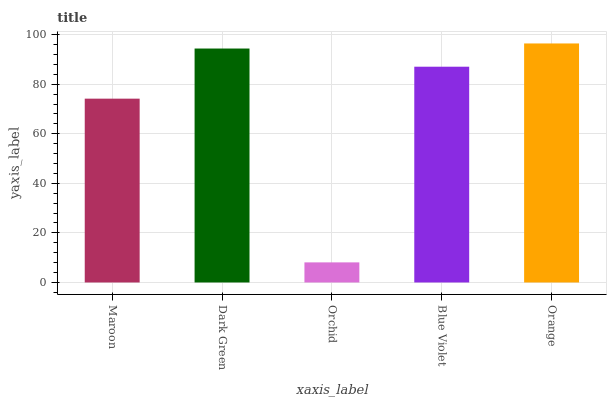Is Orchid the minimum?
Answer yes or no. Yes. Is Orange the maximum?
Answer yes or no. Yes. Is Dark Green the minimum?
Answer yes or no. No. Is Dark Green the maximum?
Answer yes or no. No. Is Dark Green greater than Maroon?
Answer yes or no. Yes. Is Maroon less than Dark Green?
Answer yes or no. Yes. Is Maroon greater than Dark Green?
Answer yes or no. No. Is Dark Green less than Maroon?
Answer yes or no. No. Is Blue Violet the high median?
Answer yes or no. Yes. Is Blue Violet the low median?
Answer yes or no. Yes. Is Orchid the high median?
Answer yes or no. No. Is Orange the low median?
Answer yes or no. No. 